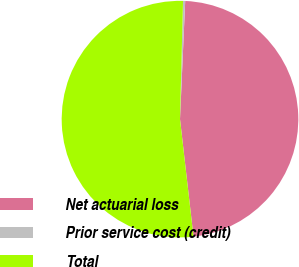Convert chart. <chart><loc_0><loc_0><loc_500><loc_500><pie_chart><fcel>Net actuarial loss<fcel>Prior service cost (credit)<fcel>Total<nl><fcel>47.48%<fcel>0.29%<fcel>52.23%<nl></chart> 